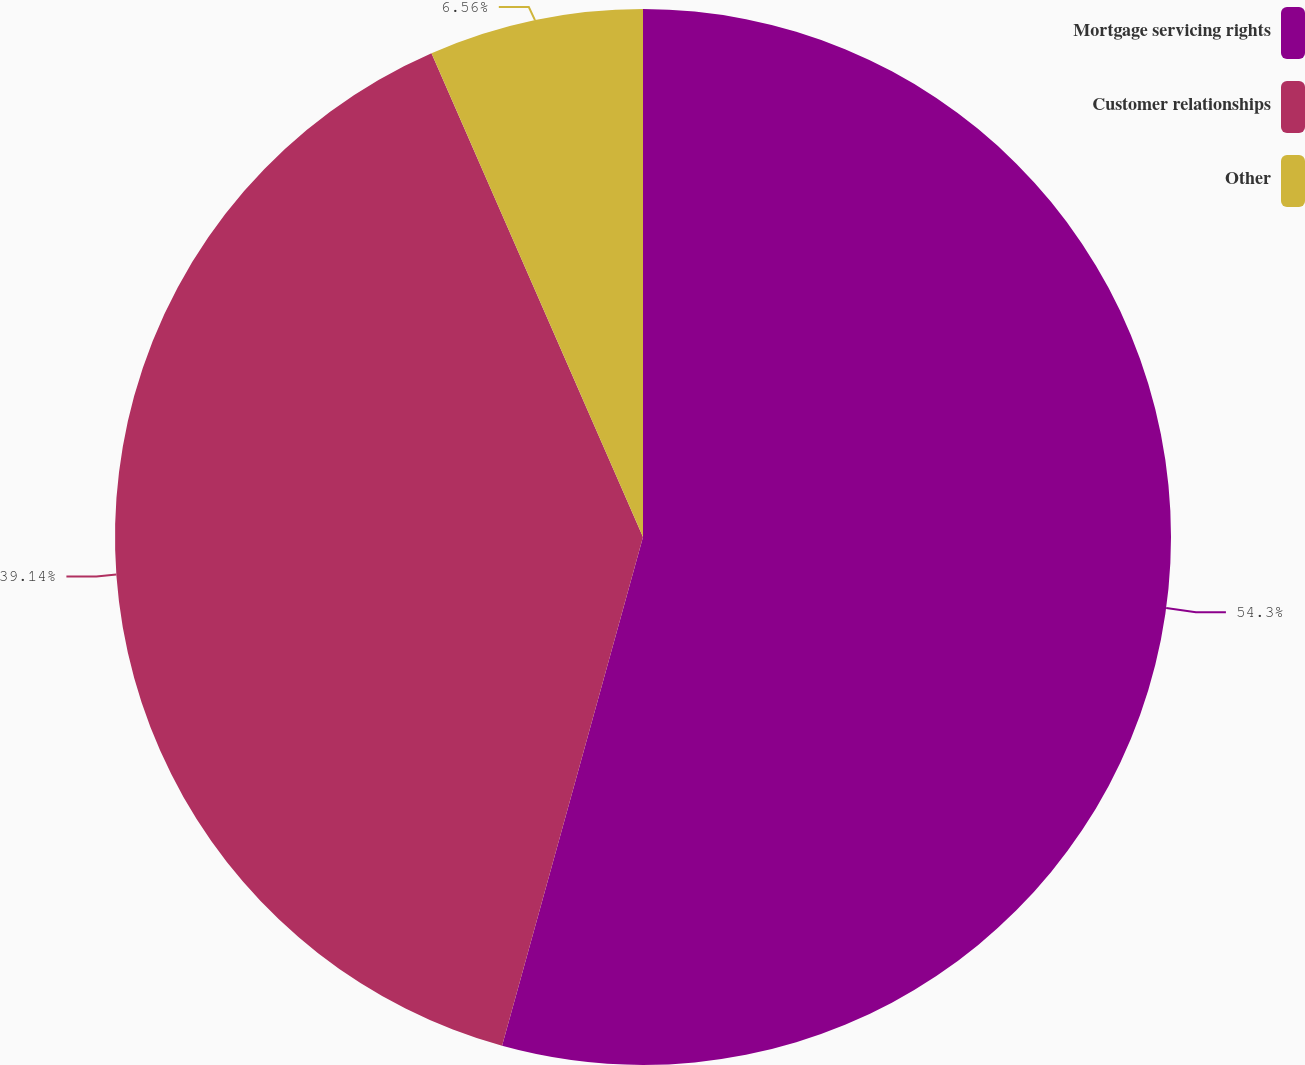Convert chart. <chart><loc_0><loc_0><loc_500><loc_500><pie_chart><fcel>Mortgage servicing rights<fcel>Customer relationships<fcel>Other<nl><fcel>54.3%<fcel>39.14%<fcel>6.56%<nl></chart> 